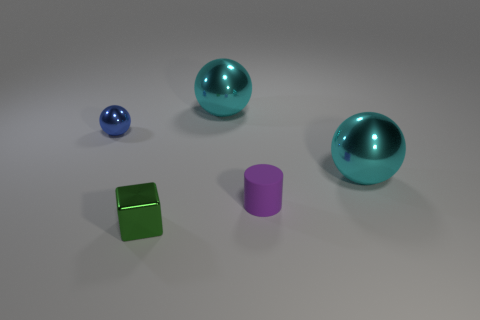There is a tiny purple matte thing; are there any big shiny objects behind it?
Give a very brief answer. Yes. Is the number of purple matte things on the left side of the blue object less than the number of yellow metallic balls?
Keep it short and to the point. No. What is the tiny blue ball made of?
Offer a very short reply. Metal. What color is the small metallic cube?
Ensure brevity in your answer.  Green. The tiny object that is to the left of the purple matte object and behind the green shiny block is what color?
Keep it short and to the point. Blue. Is there anything else that has the same material as the purple thing?
Keep it short and to the point. No. Is the material of the block the same as the tiny thing to the right of the small green metal object?
Provide a short and direct response. No. There is a cyan ball that is to the left of the small thing that is right of the tiny green metal object; how big is it?
Offer a terse response. Large. Do the big ball in front of the small ball and the tiny cylinder in front of the small blue thing have the same material?
Ensure brevity in your answer.  No. What material is the tiny thing that is to the left of the tiny rubber thing and to the right of the small sphere?
Provide a short and direct response. Metal. 